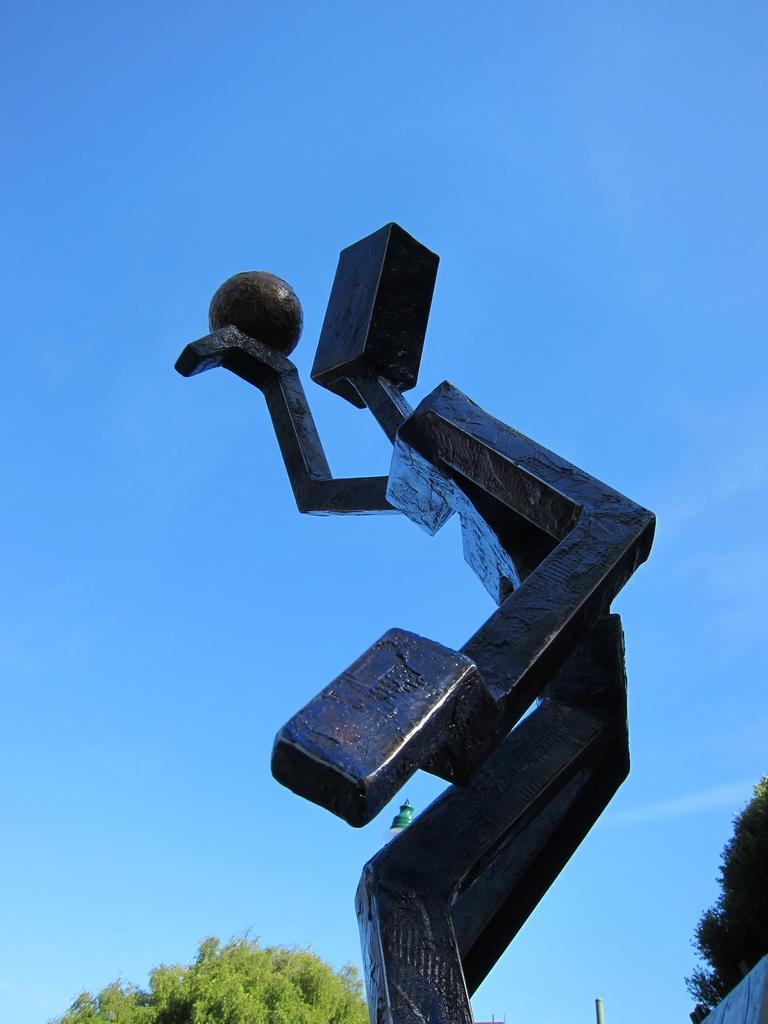Can you describe this image briefly? In this picture we can see a statue in the front, in the background there are trees, we can see the sky at the top of the picture. 